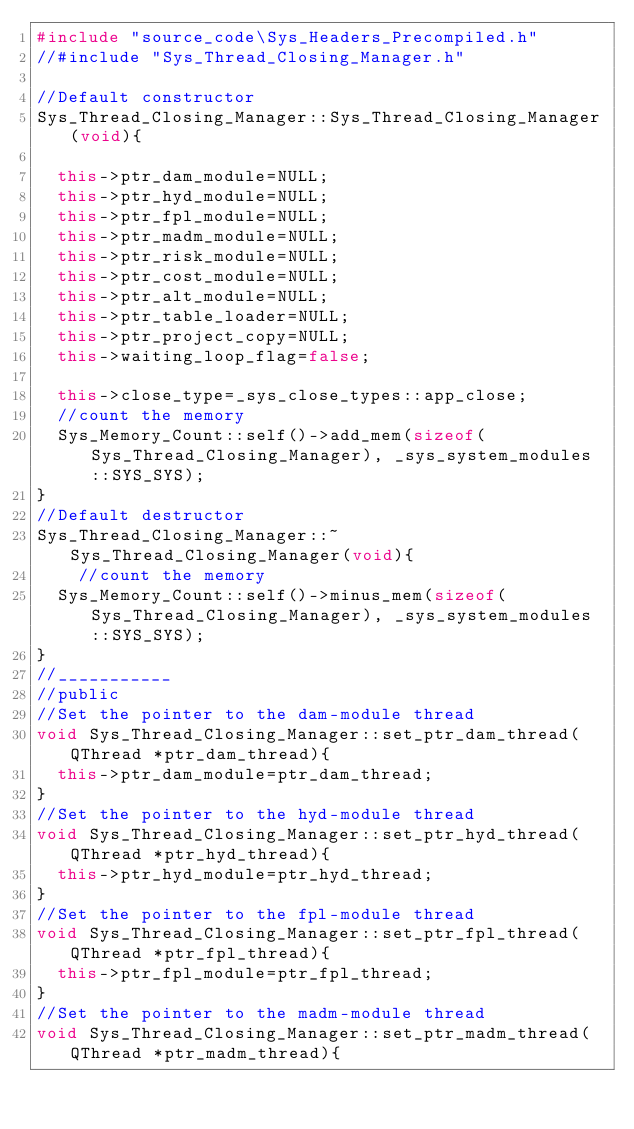Convert code to text. <code><loc_0><loc_0><loc_500><loc_500><_C++_>#include "source_code\Sys_Headers_Precompiled.h"
//#include "Sys_Thread_Closing_Manager.h"

//Default constructor
Sys_Thread_Closing_Manager::Sys_Thread_Closing_Manager(void){

	this->ptr_dam_module=NULL;
	this->ptr_hyd_module=NULL;
	this->ptr_fpl_module=NULL;
	this->ptr_madm_module=NULL;
	this->ptr_risk_module=NULL;
	this->ptr_cost_module=NULL;
	this->ptr_alt_module=NULL;
	this->ptr_table_loader=NULL;
	this->ptr_project_copy=NULL;
	this->waiting_loop_flag=false;

	this->close_type=_sys_close_types::app_close;
	//count the memory
	Sys_Memory_Count::self()->add_mem(sizeof(Sys_Thread_Closing_Manager), _sys_system_modules::SYS_SYS);
}
//Default destructor
Sys_Thread_Closing_Manager::~Sys_Thread_Closing_Manager(void){
		//count the memory
	Sys_Memory_Count::self()->minus_mem(sizeof(Sys_Thread_Closing_Manager), _sys_system_modules::SYS_SYS);
}
//___________
//public
//Set the pointer to the dam-module thread
void Sys_Thread_Closing_Manager::set_ptr_dam_thread(QThread *ptr_dam_thread){
	this->ptr_dam_module=ptr_dam_thread;
}
//Set the pointer to the hyd-module thread
void Sys_Thread_Closing_Manager::set_ptr_hyd_thread(QThread *ptr_hyd_thread){
	this->ptr_hyd_module=ptr_hyd_thread;
}
//Set the pointer to the fpl-module thread
void Sys_Thread_Closing_Manager::set_ptr_fpl_thread(QThread *ptr_fpl_thread){
	this->ptr_fpl_module=ptr_fpl_thread;
}
//Set the pointer to the madm-module thread
void Sys_Thread_Closing_Manager::set_ptr_madm_thread(QThread *ptr_madm_thread){</code> 